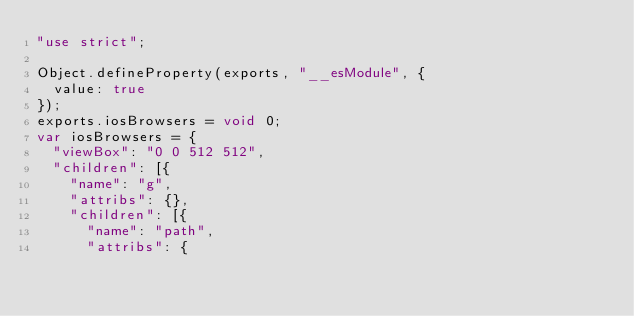Convert code to text. <code><loc_0><loc_0><loc_500><loc_500><_JavaScript_>"use strict";

Object.defineProperty(exports, "__esModule", {
  value: true
});
exports.iosBrowsers = void 0;
var iosBrowsers = {
  "viewBox": "0 0 512 512",
  "children": [{
    "name": "g",
    "attribs": {},
    "children": [{
      "name": "path",
      "attribs": {</code> 